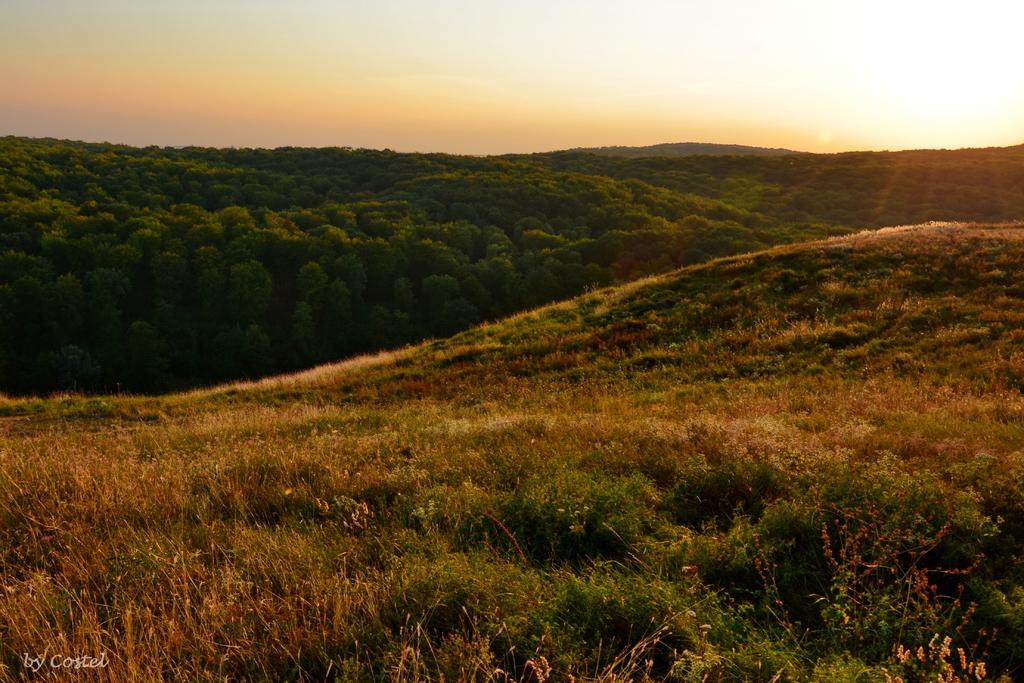What type of vegetation is present in the image? There is a group of plants and trees in the image. Where are the plants and trees located? The plants and trees are on hills. What can be seen in the sky in the image? The sun is visible in the image, and the sky appears cloudy. How many icicles are hanging from the trees in the image? There are no icicles present in the image, as it is not a winter scene and the trees are not covered in ice. 